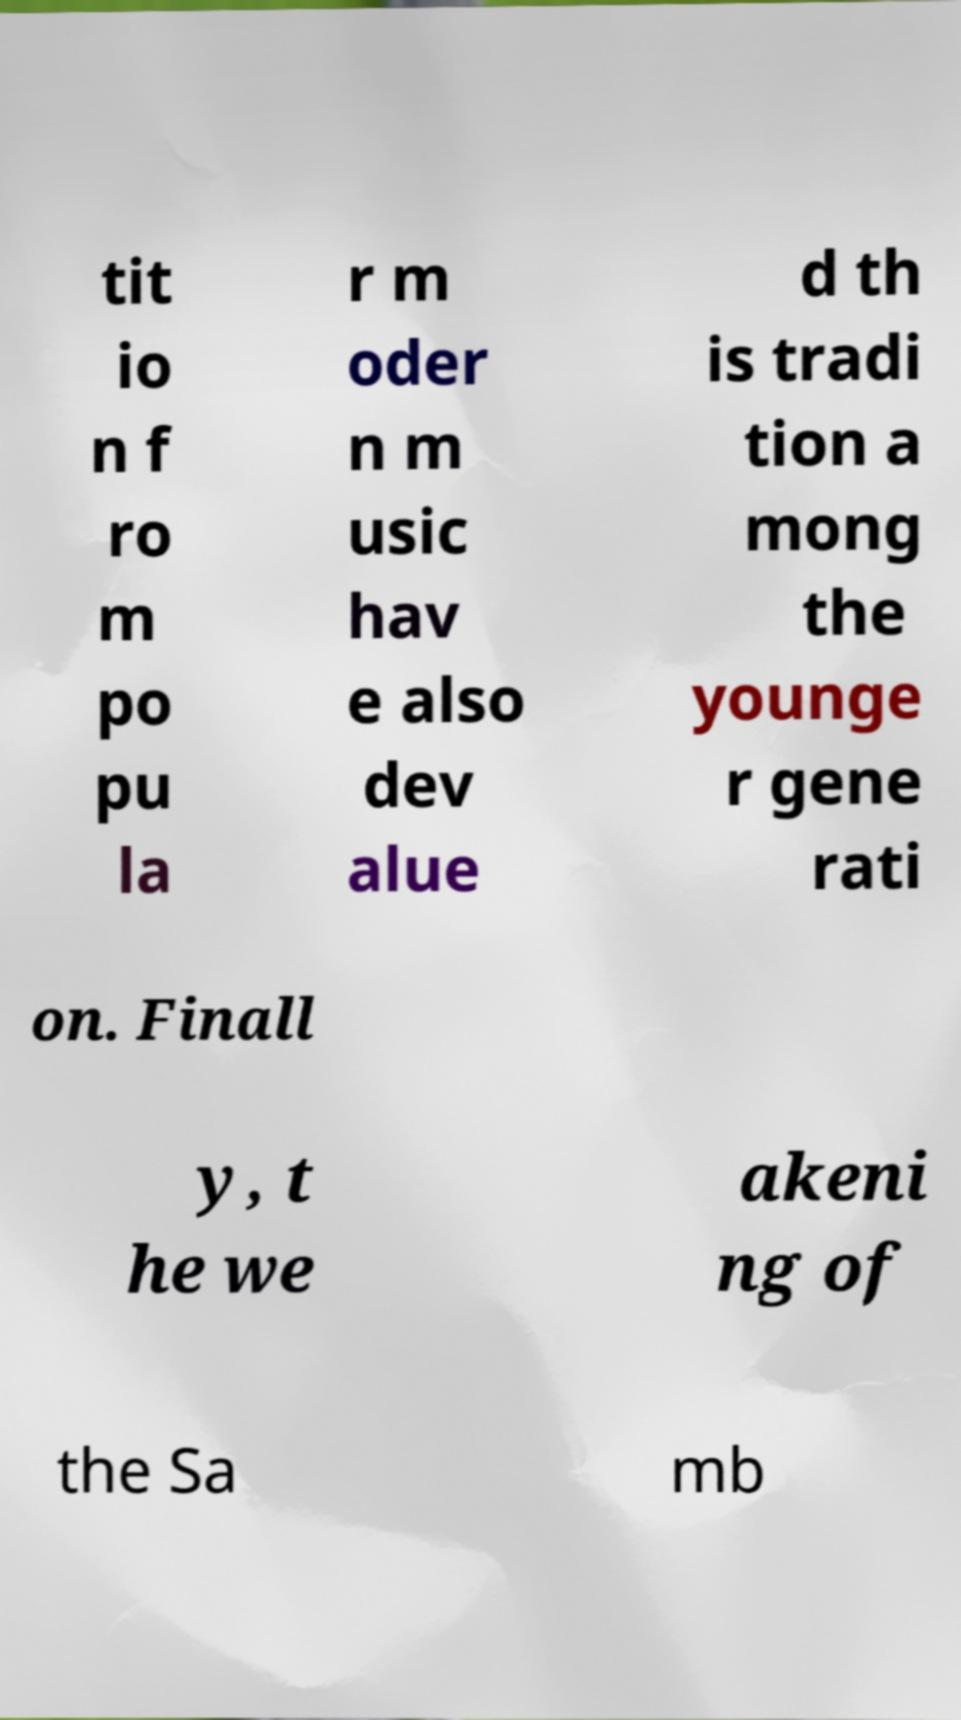For documentation purposes, I need the text within this image transcribed. Could you provide that? tit io n f ro m po pu la r m oder n m usic hav e also dev alue d th is tradi tion a mong the younge r gene rati on. Finall y, t he we akeni ng of the Sa mb 